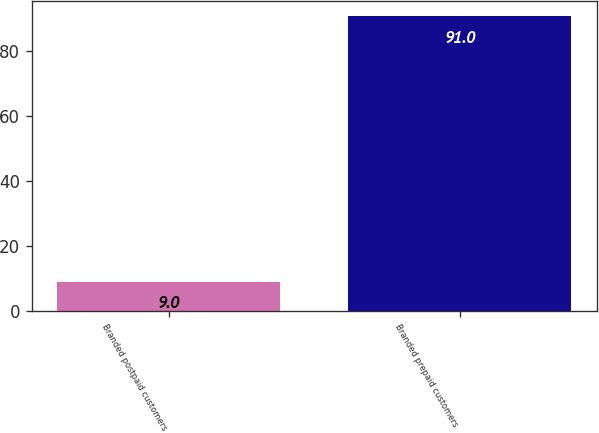Convert chart. <chart><loc_0><loc_0><loc_500><loc_500><bar_chart><fcel>Branded postpaid customers<fcel>Branded prepaid customers<nl><fcel>9<fcel>91<nl></chart> 